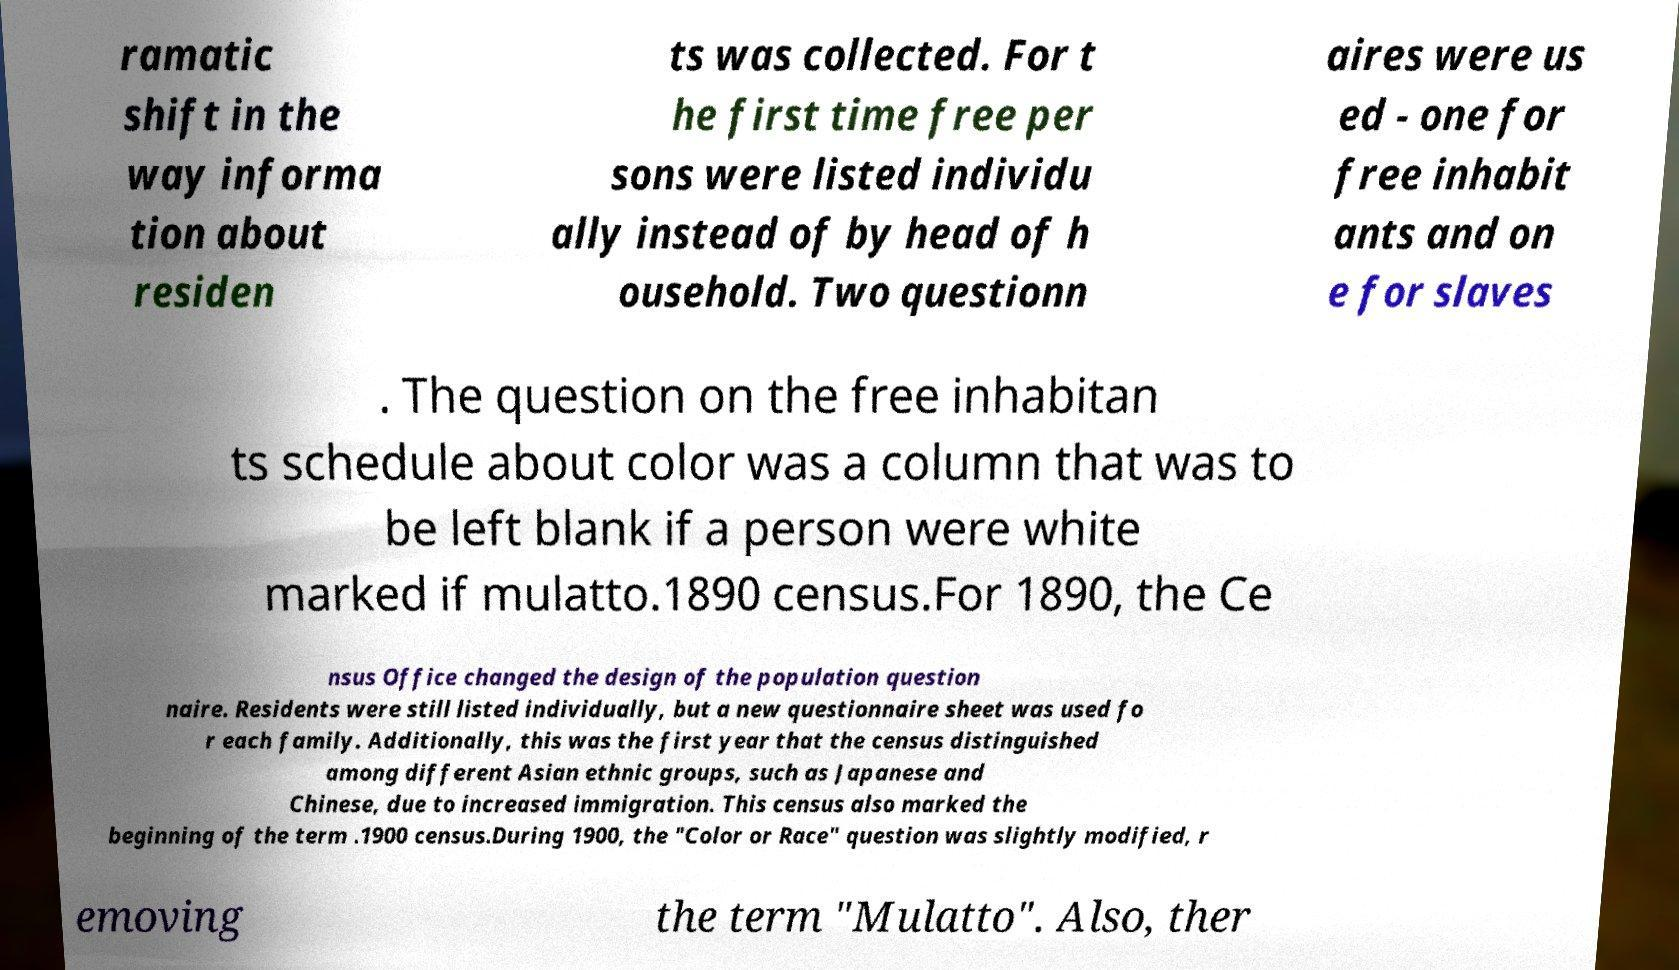There's text embedded in this image that I need extracted. Can you transcribe it verbatim? ramatic shift in the way informa tion about residen ts was collected. For t he first time free per sons were listed individu ally instead of by head of h ousehold. Two questionn aires were us ed - one for free inhabit ants and on e for slaves . The question on the free inhabitan ts schedule about color was a column that was to be left blank if a person were white marked if mulatto.1890 census.For 1890, the Ce nsus Office changed the design of the population question naire. Residents were still listed individually, but a new questionnaire sheet was used fo r each family. Additionally, this was the first year that the census distinguished among different Asian ethnic groups, such as Japanese and Chinese, due to increased immigration. This census also marked the beginning of the term .1900 census.During 1900, the "Color or Race" question was slightly modified, r emoving the term "Mulatto". Also, ther 